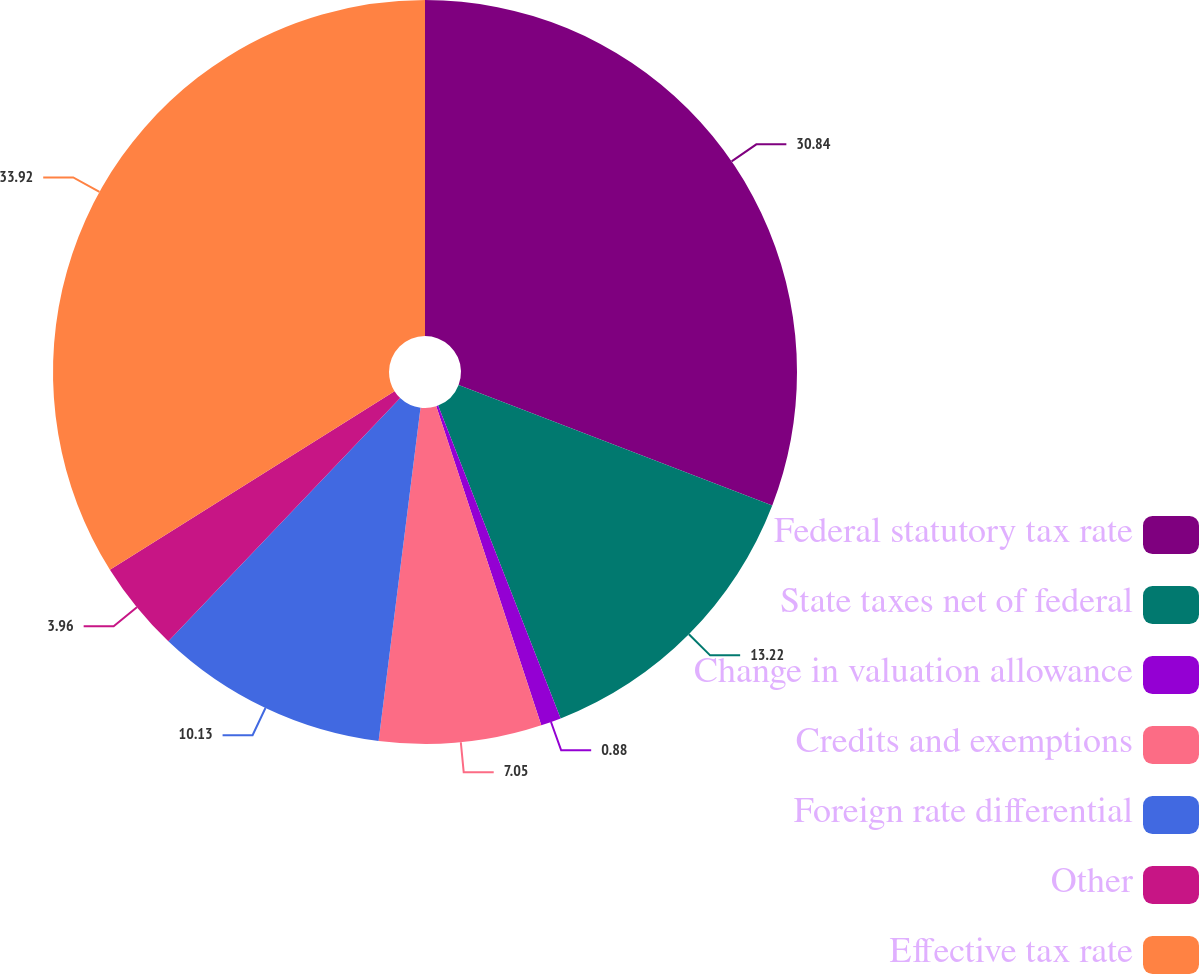Convert chart to OTSL. <chart><loc_0><loc_0><loc_500><loc_500><pie_chart><fcel>Federal statutory tax rate<fcel>State taxes net of federal<fcel>Change in valuation allowance<fcel>Credits and exemptions<fcel>Foreign rate differential<fcel>Other<fcel>Effective tax rate<nl><fcel>30.84%<fcel>13.22%<fcel>0.88%<fcel>7.05%<fcel>10.13%<fcel>3.96%<fcel>33.92%<nl></chart> 